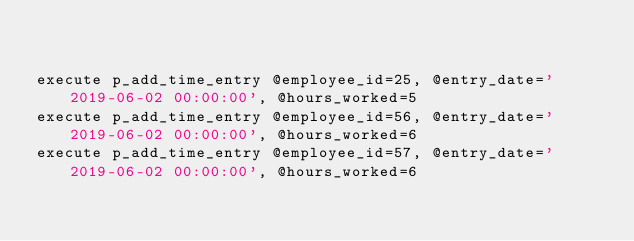Convert code to text. <code><loc_0><loc_0><loc_500><loc_500><_SQL_>

execute p_add_time_entry @employee_id=25, @entry_date='2019-06-02 00:00:00', @hours_worked=5
execute p_add_time_entry @employee_id=56, @entry_date='2019-06-02 00:00:00', @hours_worked=6
execute p_add_time_entry @employee_id=57, @entry_date='2019-06-02 00:00:00', @hours_worked=6</code> 